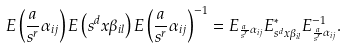Convert formula to latex. <formula><loc_0><loc_0><loc_500><loc_500>E \left ( \frac { a } { s ^ { r } } \alpha _ { i j } \right ) E \left ( s ^ { d } x \beta _ { i l } \right ) E \left ( \frac { a } { s ^ { r } } \alpha _ { i j } \right ) ^ { - 1 } = E _ { \frac { a } { s ^ { r } } \alpha _ { i j } } E _ { s ^ { d } x \beta _ { i l } } ^ { * } E _ { \frac { a } { s ^ { r } } \alpha _ { i j } } ^ { - 1 } .</formula> 